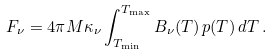<formula> <loc_0><loc_0><loc_500><loc_500>F _ { \nu } = 4 \pi M \kappa _ { \nu } \int _ { T _ { \min } } ^ { T _ { \max } } B _ { \nu } ( T ) \, p ( T ) \, d T \, .</formula> 